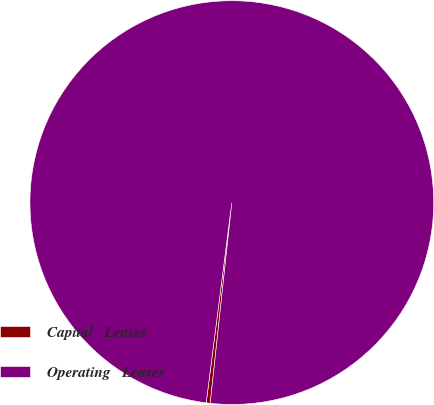Convert chart to OTSL. <chart><loc_0><loc_0><loc_500><loc_500><pie_chart><fcel>Capital   Leases<fcel>Operating   Leases<nl><fcel>0.32%<fcel>99.68%<nl></chart> 